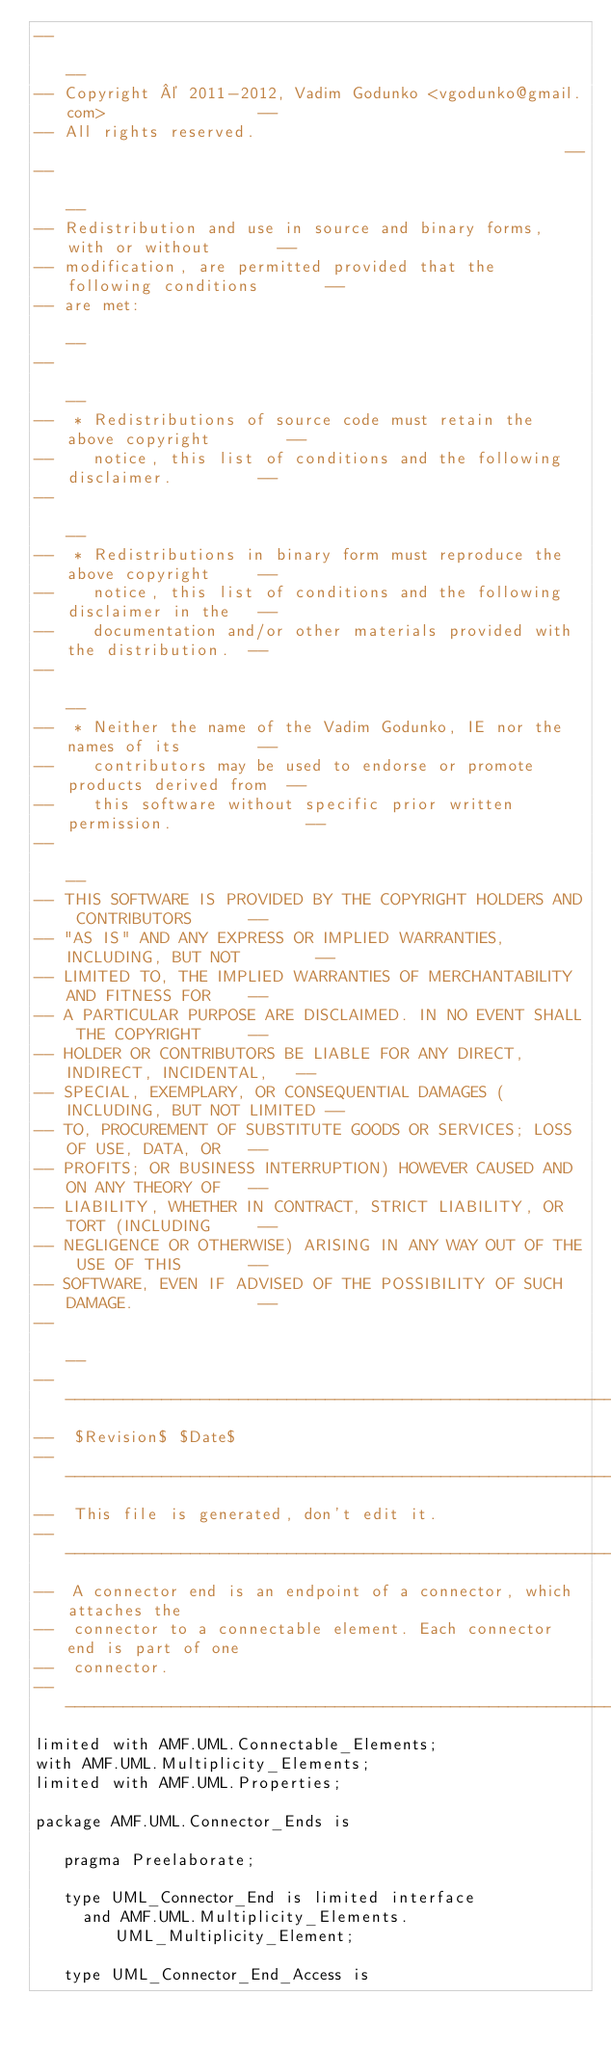<code> <loc_0><loc_0><loc_500><loc_500><_Ada_>--                                                                          --
-- Copyright © 2011-2012, Vadim Godunko <vgodunko@gmail.com>                --
-- All rights reserved.                                                     --
--                                                                          --
-- Redistribution and use in source and binary forms, with or without       --
-- modification, are permitted provided that the following conditions       --
-- are met:                                                                 --
--                                                                          --
--  * Redistributions of source code must retain the above copyright        --
--    notice, this list of conditions and the following disclaimer.         --
--                                                                          --
--  * Redistributions in binary form must reproduce the above copyright     --
--    notice, this list of conditions and the following disclaimer in the   --
--    documentation and/or other materials provided with the distribution.  --
--                                                                          --
--  * Neither the name of the Vadim Godunko, IE nor the names of its        --
--    contributors may be used to endorse or promote products derived from  --
--    this software without specific prior written permission.              --
--                                                                          --
-- THIS SOFTWARE IS PROVIDED BY THE COPYRIGHT HOLDERS AND CONTRIBUTORS      --
-- "AS IS" AND ANY EXPRESS OR IMPLIED WARRANTIES, INCLUDING, BUT NOT        --
-- LIMITED TO, THE IMPLIED WARRANTIES OF MERCHANTABILITY AND FITNESS FOR    --
-- A PARTICULAR PURPOSE ARE DISCLAIMED. IN NO EVENT SHALL THE COPYRIGHT     --
-- HOLDER OR CONTRIBUTORS BE LIABLE FOR ANY DIRECT, INDIRECT, INCIDENTAL,   --
-- SPECIAL, EXEMPLARY, OR CONSEQUENTIAL DAMAGES (INCLUDING, BUT NOT LIMITED --
-- TO, PROCUREMENT OF SUBSTITUTE GOODS OR SERVICES; LOSS OF USE, DATA, OR   --
-- PROFITS; OR BUSINESS INTERRUPTION) HOWEVER CAUSED AND ON ANY THEORY OF   --
-- LIABILITY, WHETHER IN CONTRACT, STRICT LIABILITY, OR TORT (INCLUDING     --
-- NEGLIGENCE OR OTHERWISE) ARISING IN ANY WAY OUT OF THE USE OF THIS       --
-- SOFTWARE, EVEN IF ADVISED OF THE POSSIBILITY OF SUCH DAMAGE.             --
--                                                                          --
------------------------------------------------------------------------------
--  $Revision$ $Date$
------------------------------------------------------------------------------
--  This file is generated, don't edit it.
------------------------------------------------------------------------------
--  A connector end is an endpoint of a connector, which attaches the 
--  connector to a connectable element. Each connector end is part of one 
--  connector.
------------------------------------------------------------------------------
limited with AMF.UML.Connectable_Elements;
with AMF.UML.Multiplicity_Elements;
limited with AMF.UML.Properties;

package AMF.UML.Connector_Ends is

   pragma Preelaborate;

   type UML_Connector_End is limited interface
     and AMF.UML.Multiplicity_Elements.UML_Multiplicity_Element;

   type UML_Connector_End_Access is</code> 